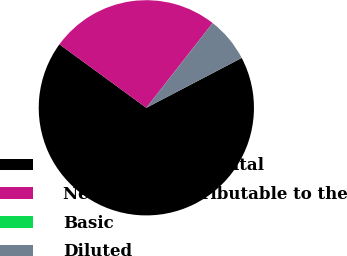<chart> <loc_0><loc_0><loc_500><loc_500><pie_chart><fcel>Revenues from rental<fcel>Net income attributable to the<fcel>Basic<fcel>Diluted<nl><fcel>67.7%<fcel>25.52%<fcel>0.0%<fcel>6.77%<nl></chart> 